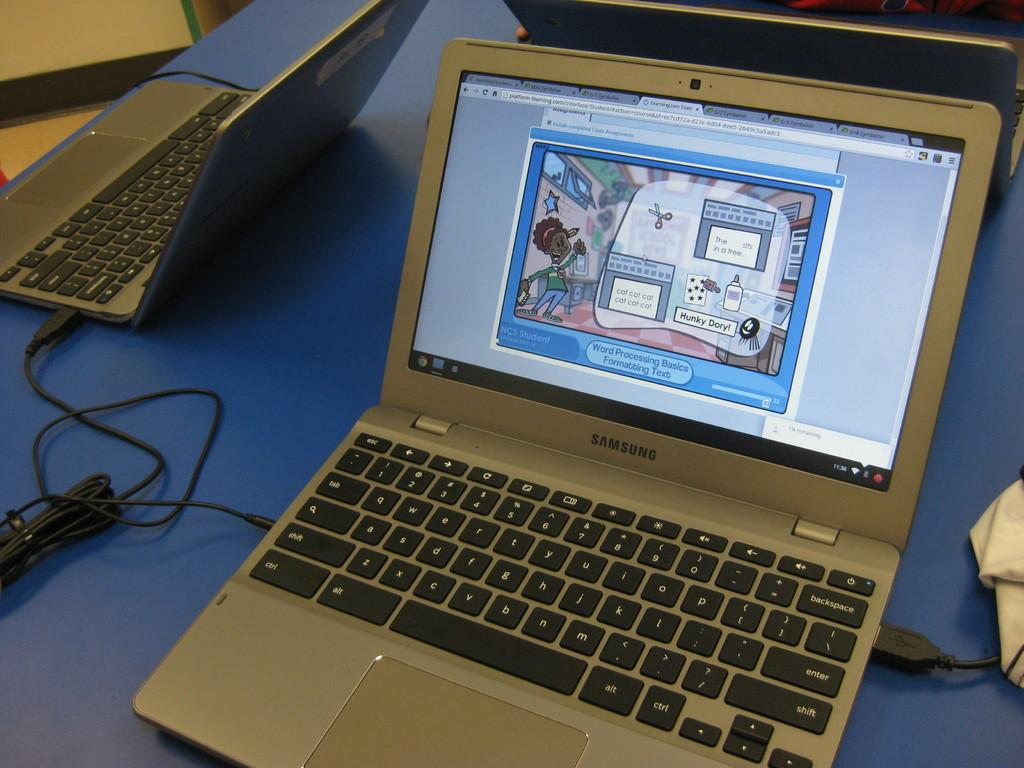<image>
Relay a brief, clear account of the picture shown. A Samsung laptop with an NCS Student application running on it. 